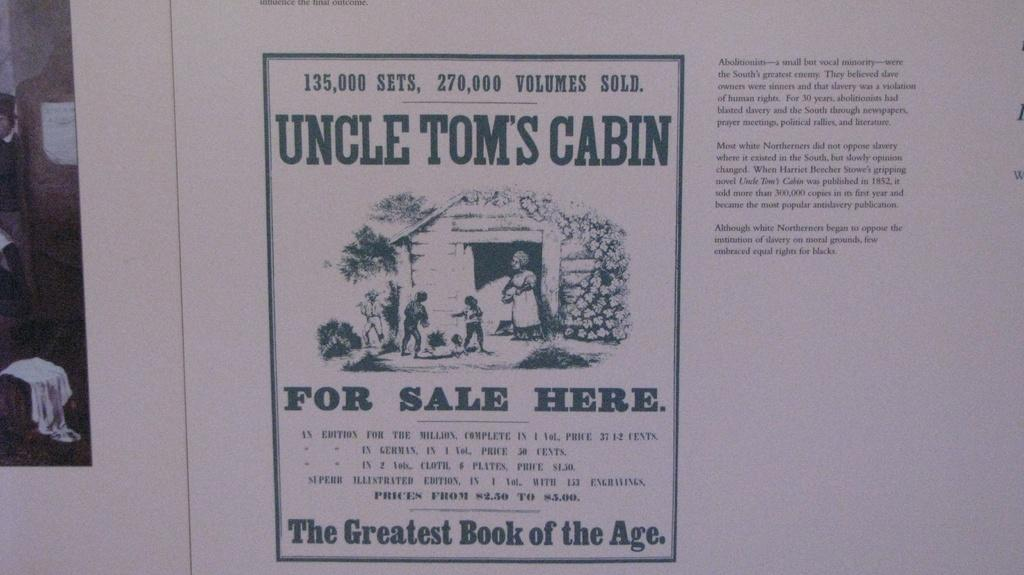Provide a one-sentence caption for the provided image. Paper that says "Uncle Tom's Cabin which is 135,000 sets. 